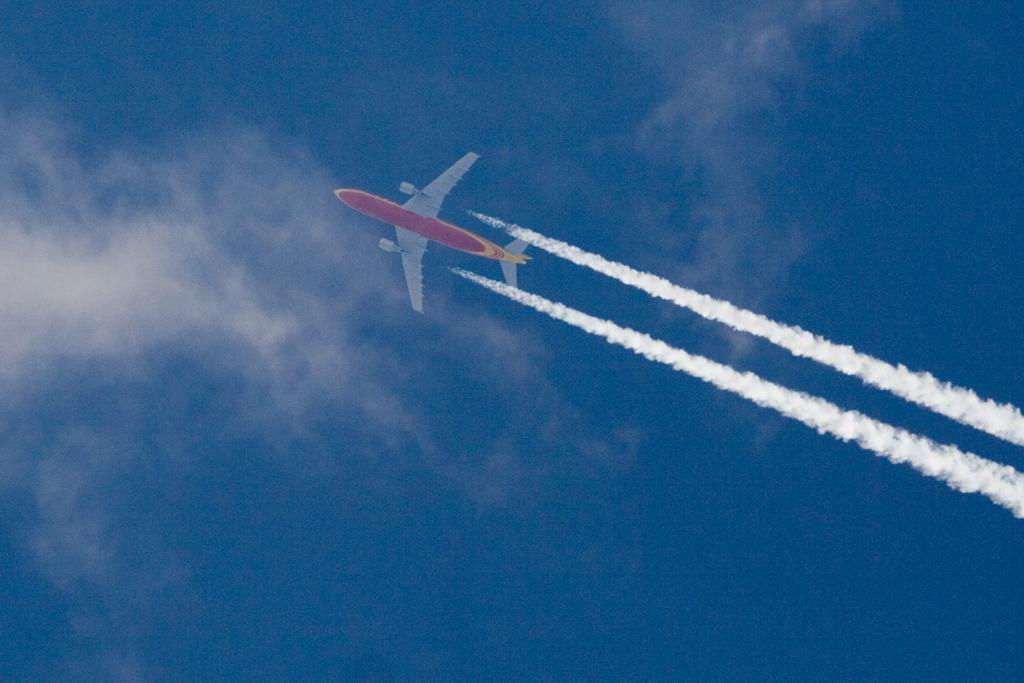What is the main subject in the sky in the image? There is an aircraft in the sky in the image. What can be seen on the right side of the image? There is smoke on the right side of the image. What is visible at the top of the image? The sky is visible at the top of the image. What can be observed in the sky besides the aircraft? There are clouds in the sky. Where is the pig located in the image? There is no pig present in the image. What type of brass instrument can be heard playing in the image? There is no brass instrument or sound present in the image. 